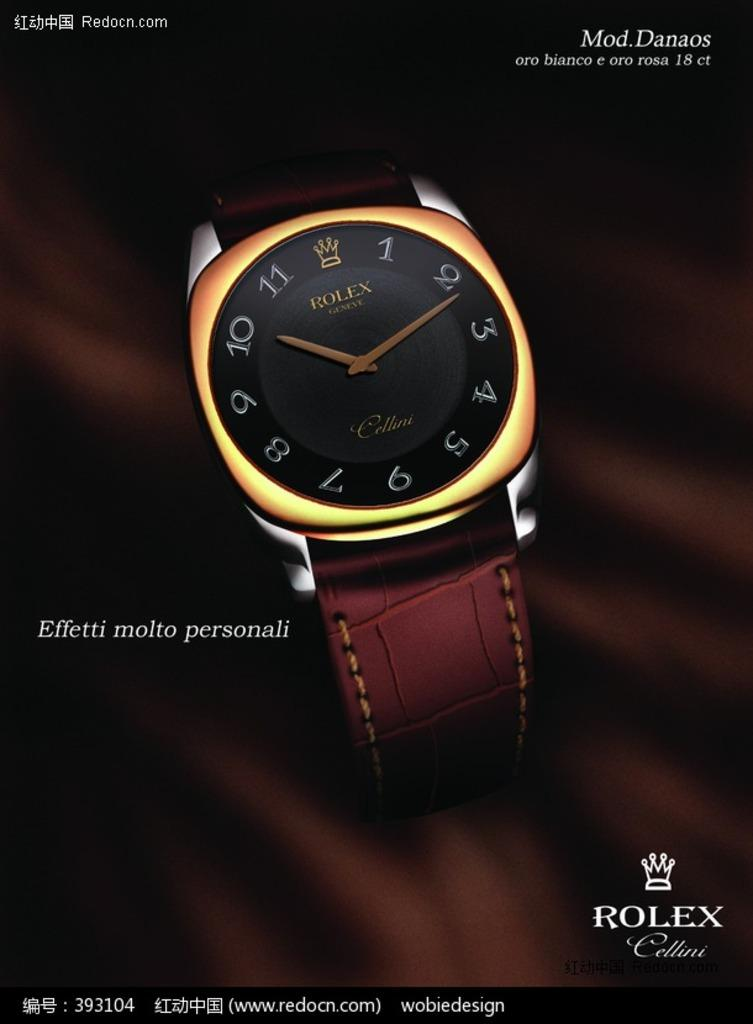<image>
Summarize the visual content of the image. An advertisement for a new Rolex Cellini watch. 